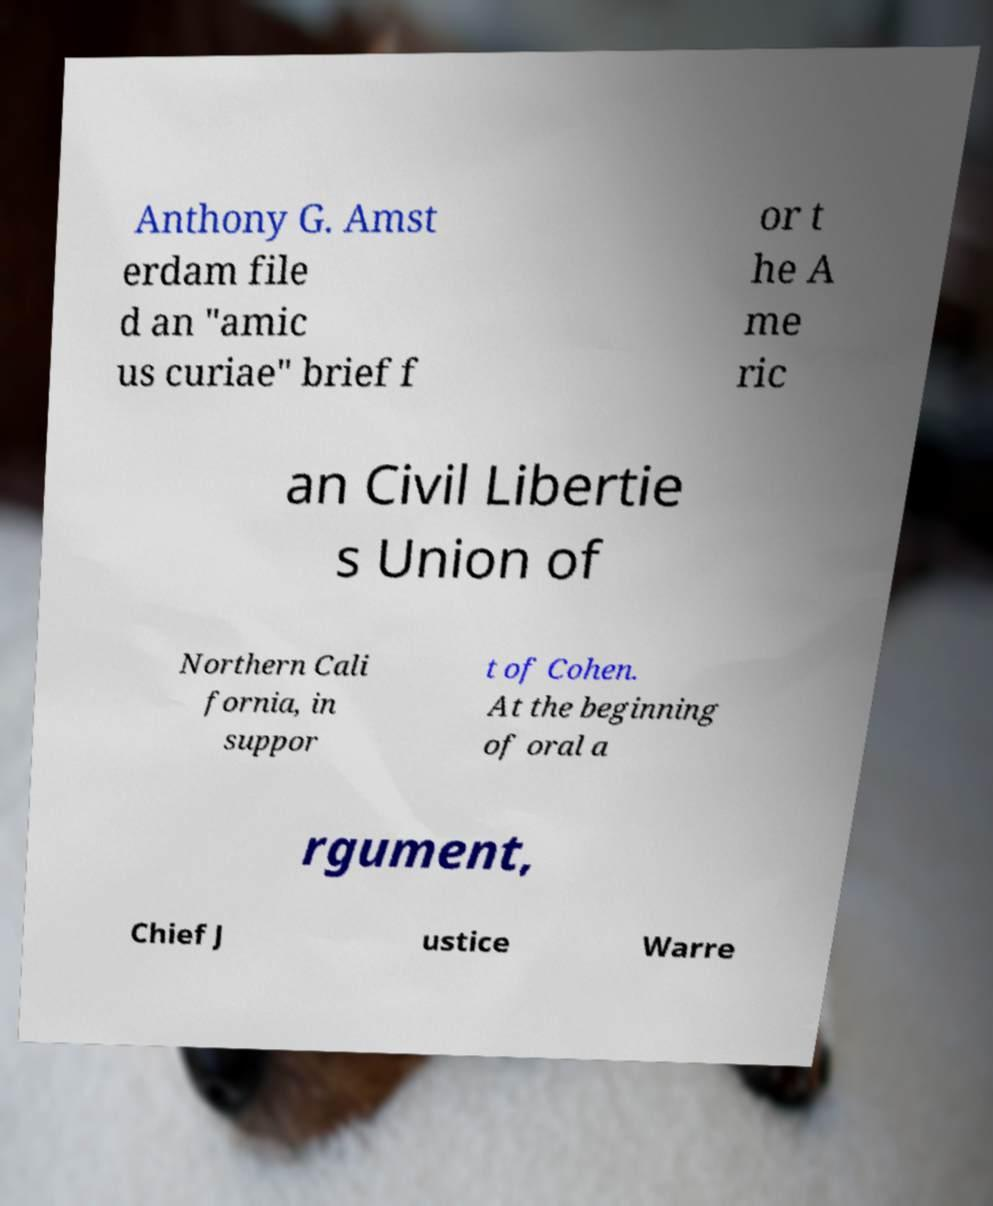What messages or text are displayed in this image? I need them in a readable, typed format. Anthony G. Amst erdam file d an "amic us curiae" brief f or t he A me ric an Civil Libertie s Union of Northern Cali fornia, in suppor t of Cohen. At the beginning of oral a rgument, Chief J ustice Warre 